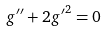Convert formula to latex. <formula><loc_0><loc_0><loc_500><loc_500>g ^ { \prime \prime } + 2 { g ^ { \prime } } ^ { 2 } = 0</formula> 